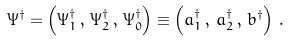<formula> <loc_0><loc_0><loc_500><loc_500>\Psi ^ { \dagger } = \left ( \Psi _ { 1 } ^ { \dagger } \, , \, \Psi _ { 2 } ^ { \dagger } \, , \, \Psi _ { 0 } ^ { \dagger } \right ) \equiv \left ( a _ { 1 } ^ { \dagger } \, , \, a _ { 2 } ^ { \dagger } \, , \, b ^ { \dagger } \right ) \, .</formula> 